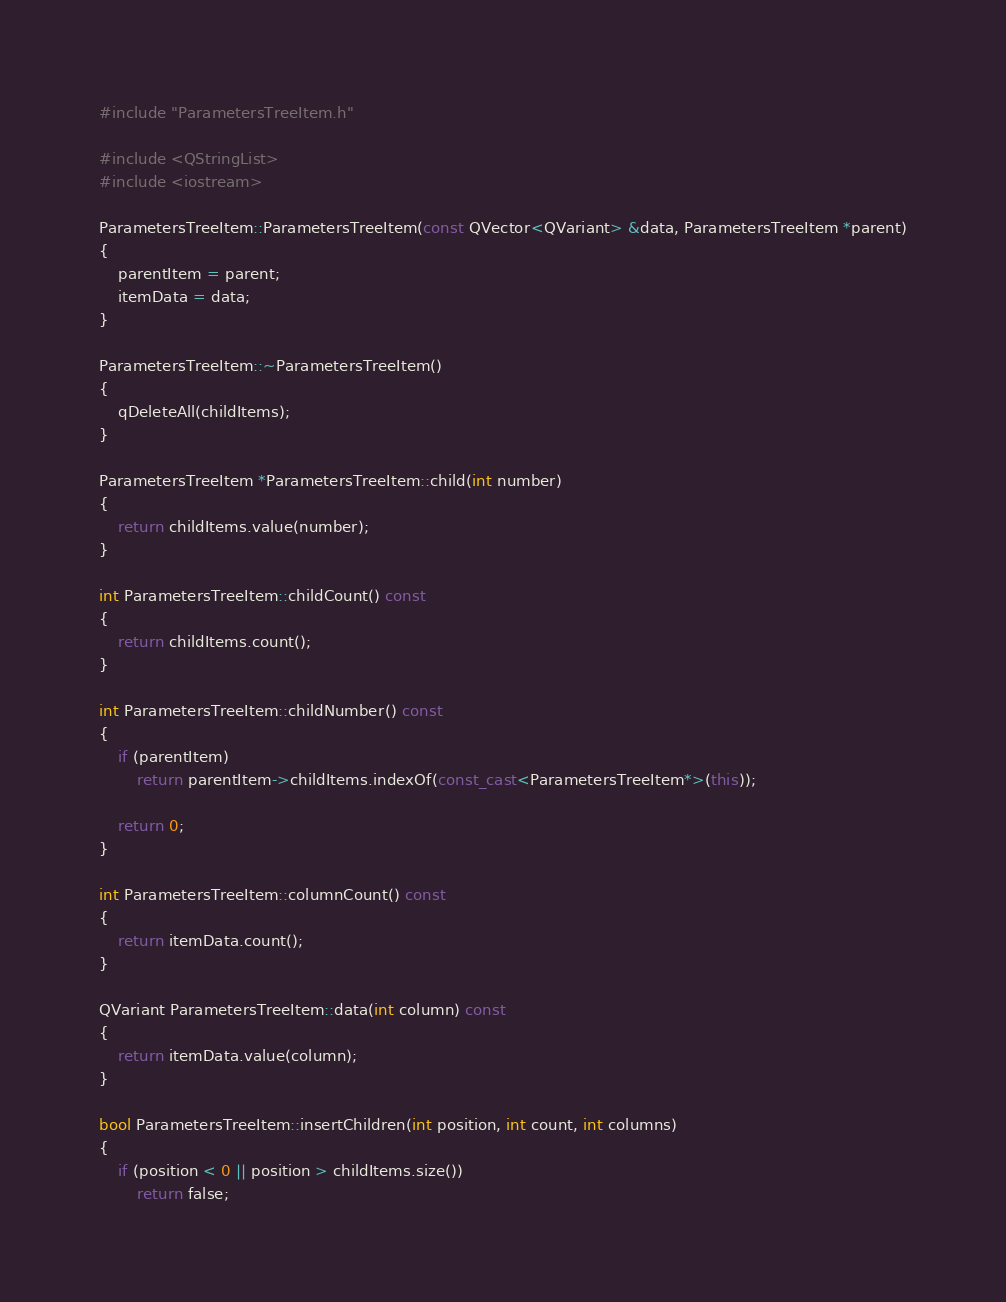<code> <loc_0><loc_0><loc_500><loc_500><_C++_>#include "ParametersTreeItem.h"

#include <QStringList>
#include <iostream>

ParametersTreeItem::ParametersTreeItem(const QVector<QVariant> &data, ParametersTreeItem *parent)
{
    parentItem = parent;
    itemData = data;
}

ParametersTreeItem::~ParametersTreeItem()
{
    qDeleteAll(childItems);
}

ParametersTreeItem *ParametersTreeItem::child(int number)
{
    return childItems.value(number);
}

int ParametersTreeItem::childCount() const
{
    return childItems.count();
}

int ParametersTreeItem::childNumber() const
{
    if (parentItem)
        return parentItem->childItems.indexOf(const_cast<ParametersTreeItem*>(this));

    return 0;
}

int ParametersTreeItem::columnCount() const
{
    return itemData.count();
}

QVariant ParametersTreeItem::data(int column) const
{
    return itemData.value(column);
}

bool ParametersTreeItem::insertChildren(int position, int count, int columns)
{
    if (position < 0 || position > childItems.size())
        return false;
</code> 